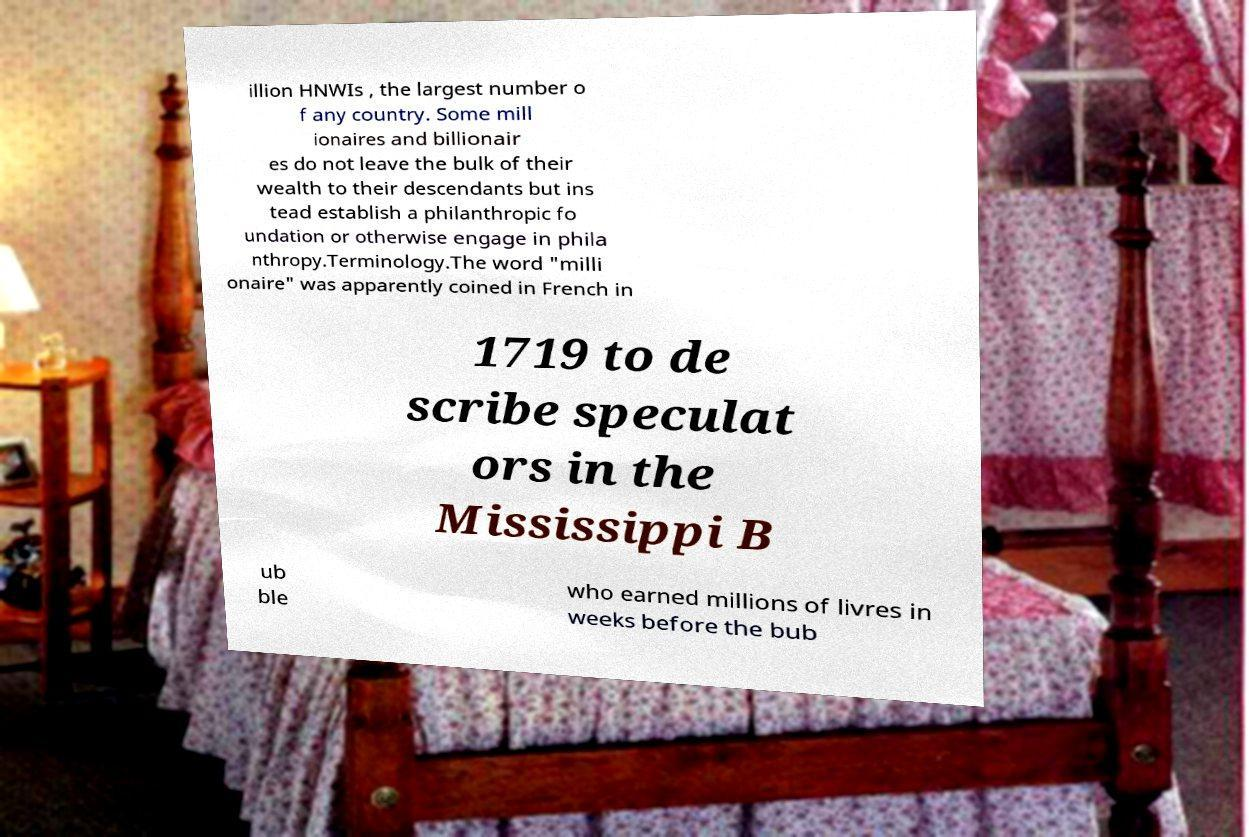There's text embedded in this image that I need extracted. Can you transcribe it verbatim? illion HNWIs , the largest number o f any country. Some mill ionaires and billionair es do not leave the bulk of their wealth to their descendants but ins tead establish a philanthropic fo undation or otherwise engage in phila nthropy.Terminology.The word "milli onaire" was apparently coined in French in 1719 to de scribe speculat ors in the Mississippi B ub ble who earned millions of livres in weeks before the bub 